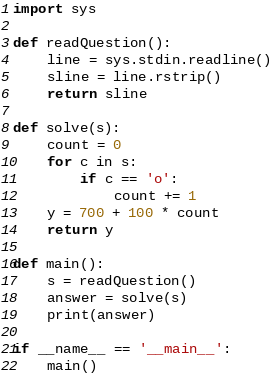Convert code to text. <code><loc_0><loc_0><loc_500><loc_500><_Python_>import sys

def readQuestion():
    line = sys.stdin.readline()
    sline = line.rstrip()
    return sline  

def solve(s):
    count = 0
    for c in s:
        if c == 'o':
            count += 1
    y = 700 + 100 * count
    return y

def main():
    s = readQuestion()
    answer = solve(s)
    print(answer)
    
if __name__ == '__main__':
    main()</code> 